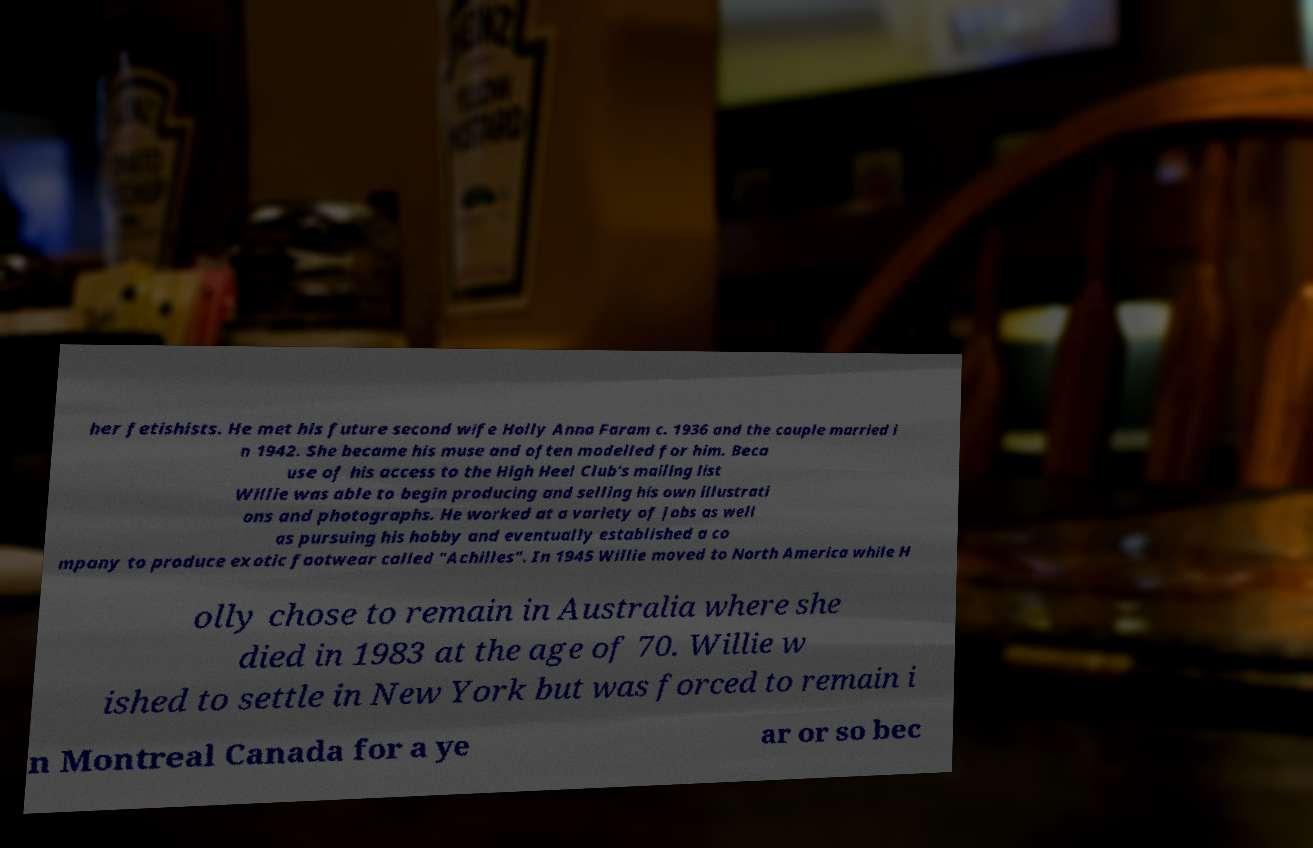Can you read and provide the text displayed in the image?This photo seems to have some interesting text. Can you extract and type it out for me? her fetishists. He met his future second wife Holly Anna Faram c. 1936 and the couple married i n 1942. She became his muse and often modelled for him. Beca use of his access to the High Heel Club's mailing list Willie was able to begin producing and selling his own illustrati ons and photographs. He worked at a variety of jobs as well as pursuing his hobby and eventually established a co mpany to produce exotic footwear called "Achilles". In 1945 Willie moved to North America while H olly chose to remain in Australia where she died in 1983 at the age of 70. Willie w ished to settle in New York but was forced to remain i n Montreal Canada for a ye ar or so bec 